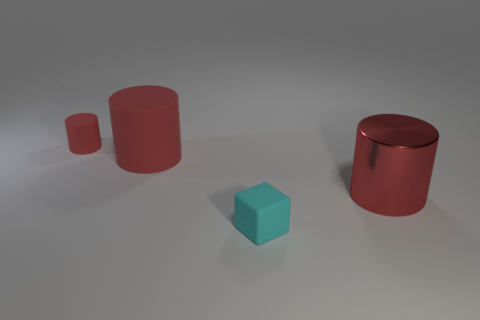Add 4 cyan matte objects. How many objects exist? 8 Subtract all cylinders. How many objects are left? 1 Subtract 1 cyan cubes. How many objects are left? 3 Subtract all rubber spheres. Subtract all large red things. How many objects are left? 2 Add 1 small red cylinders. How many small red cylinders are left? 2 Add 1 red rubber things. How many red rubber things exist? 3 